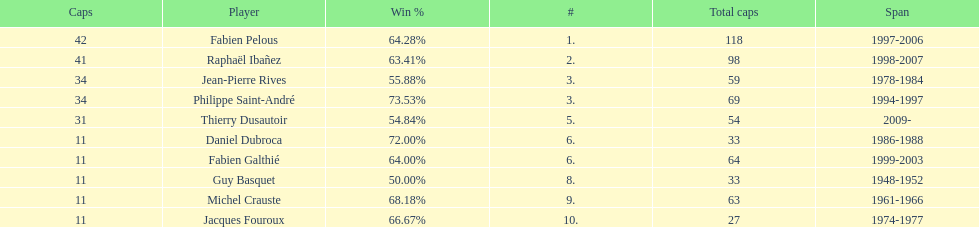How many players have spans above three years? 6. 